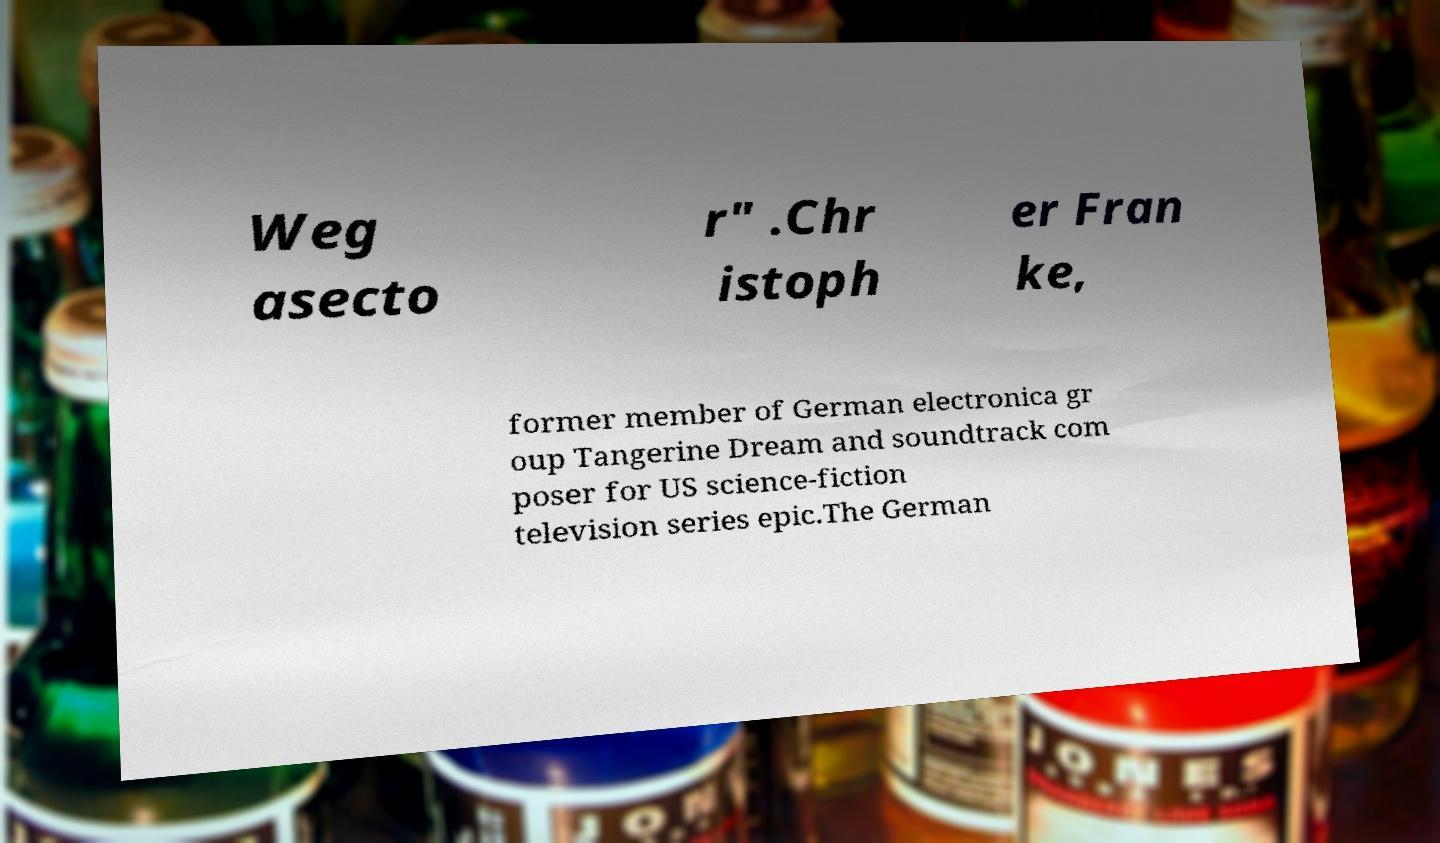For documentation purposes, I need the text within this image transcribed. Could you provide that? Weg asecto r" .Chr istoph er Fran ke, former member of German electronica gr oup Tangerine Dream and soundtrack com poser for US science-fiction television series epic.The German 